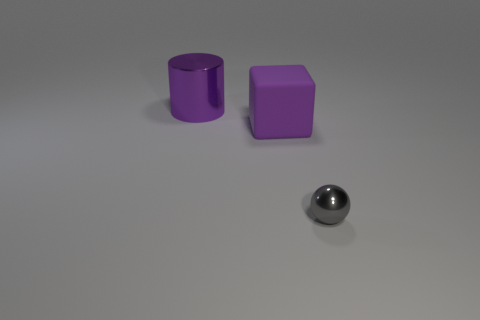Add 1 big brown shiny objects. How many objects exist? 4 Subtract all blocks. How many objects are left? 2 Subtract all big red rubber cubes. Subtract all tiny metal spheres. How many objects are left? 2 Add 2 matte things. How many matte things are left? 3 Add 1 big things. How many big things exist? 3 Subtract 1 gray balls. How many objects are left? 2 